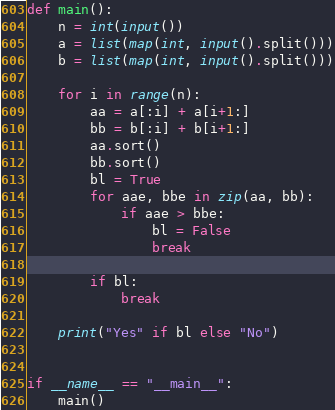<code> <loc_0><loc_0><loc_500><loc_500><_Python_>def main():
    n = int(input())
    a = list(map(int, input().split()))
    b = list(map(int, input().split()))

    for i in range(n):
        aa = a[:i] + a[i+1:]
        bb = b[:i] + b[i+1:]
        aa.sort()
        bb.sort()
        bl = True
        for aae, bbe in zip(aa, bb):
            if aae > bbe:
                bl = False
                break

        if bl:
            break

    print("Yes" if bl else "No")


if __name__ == "__main__":
    main()
</code> 